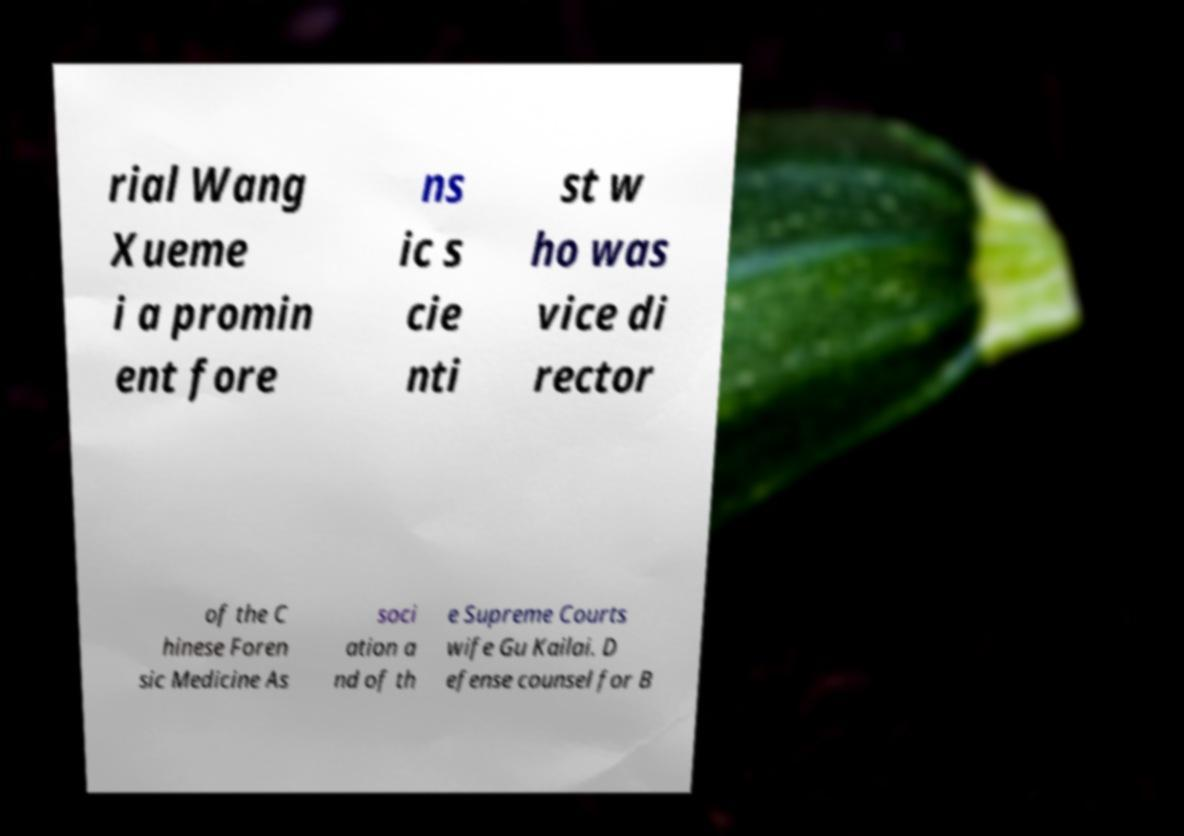Can you read and provide the text displayed in the image?This photo seems to have some interesting text. Can you extract and type it out for me? rial Wang Xueme i a promin ent fore ns ic s cie nti st w ho was vice di rector of the C hinese Foren sic Medicine As soci ation a nd of th e Supreme Courts wife Gu Kailai. D efense counsel for B 